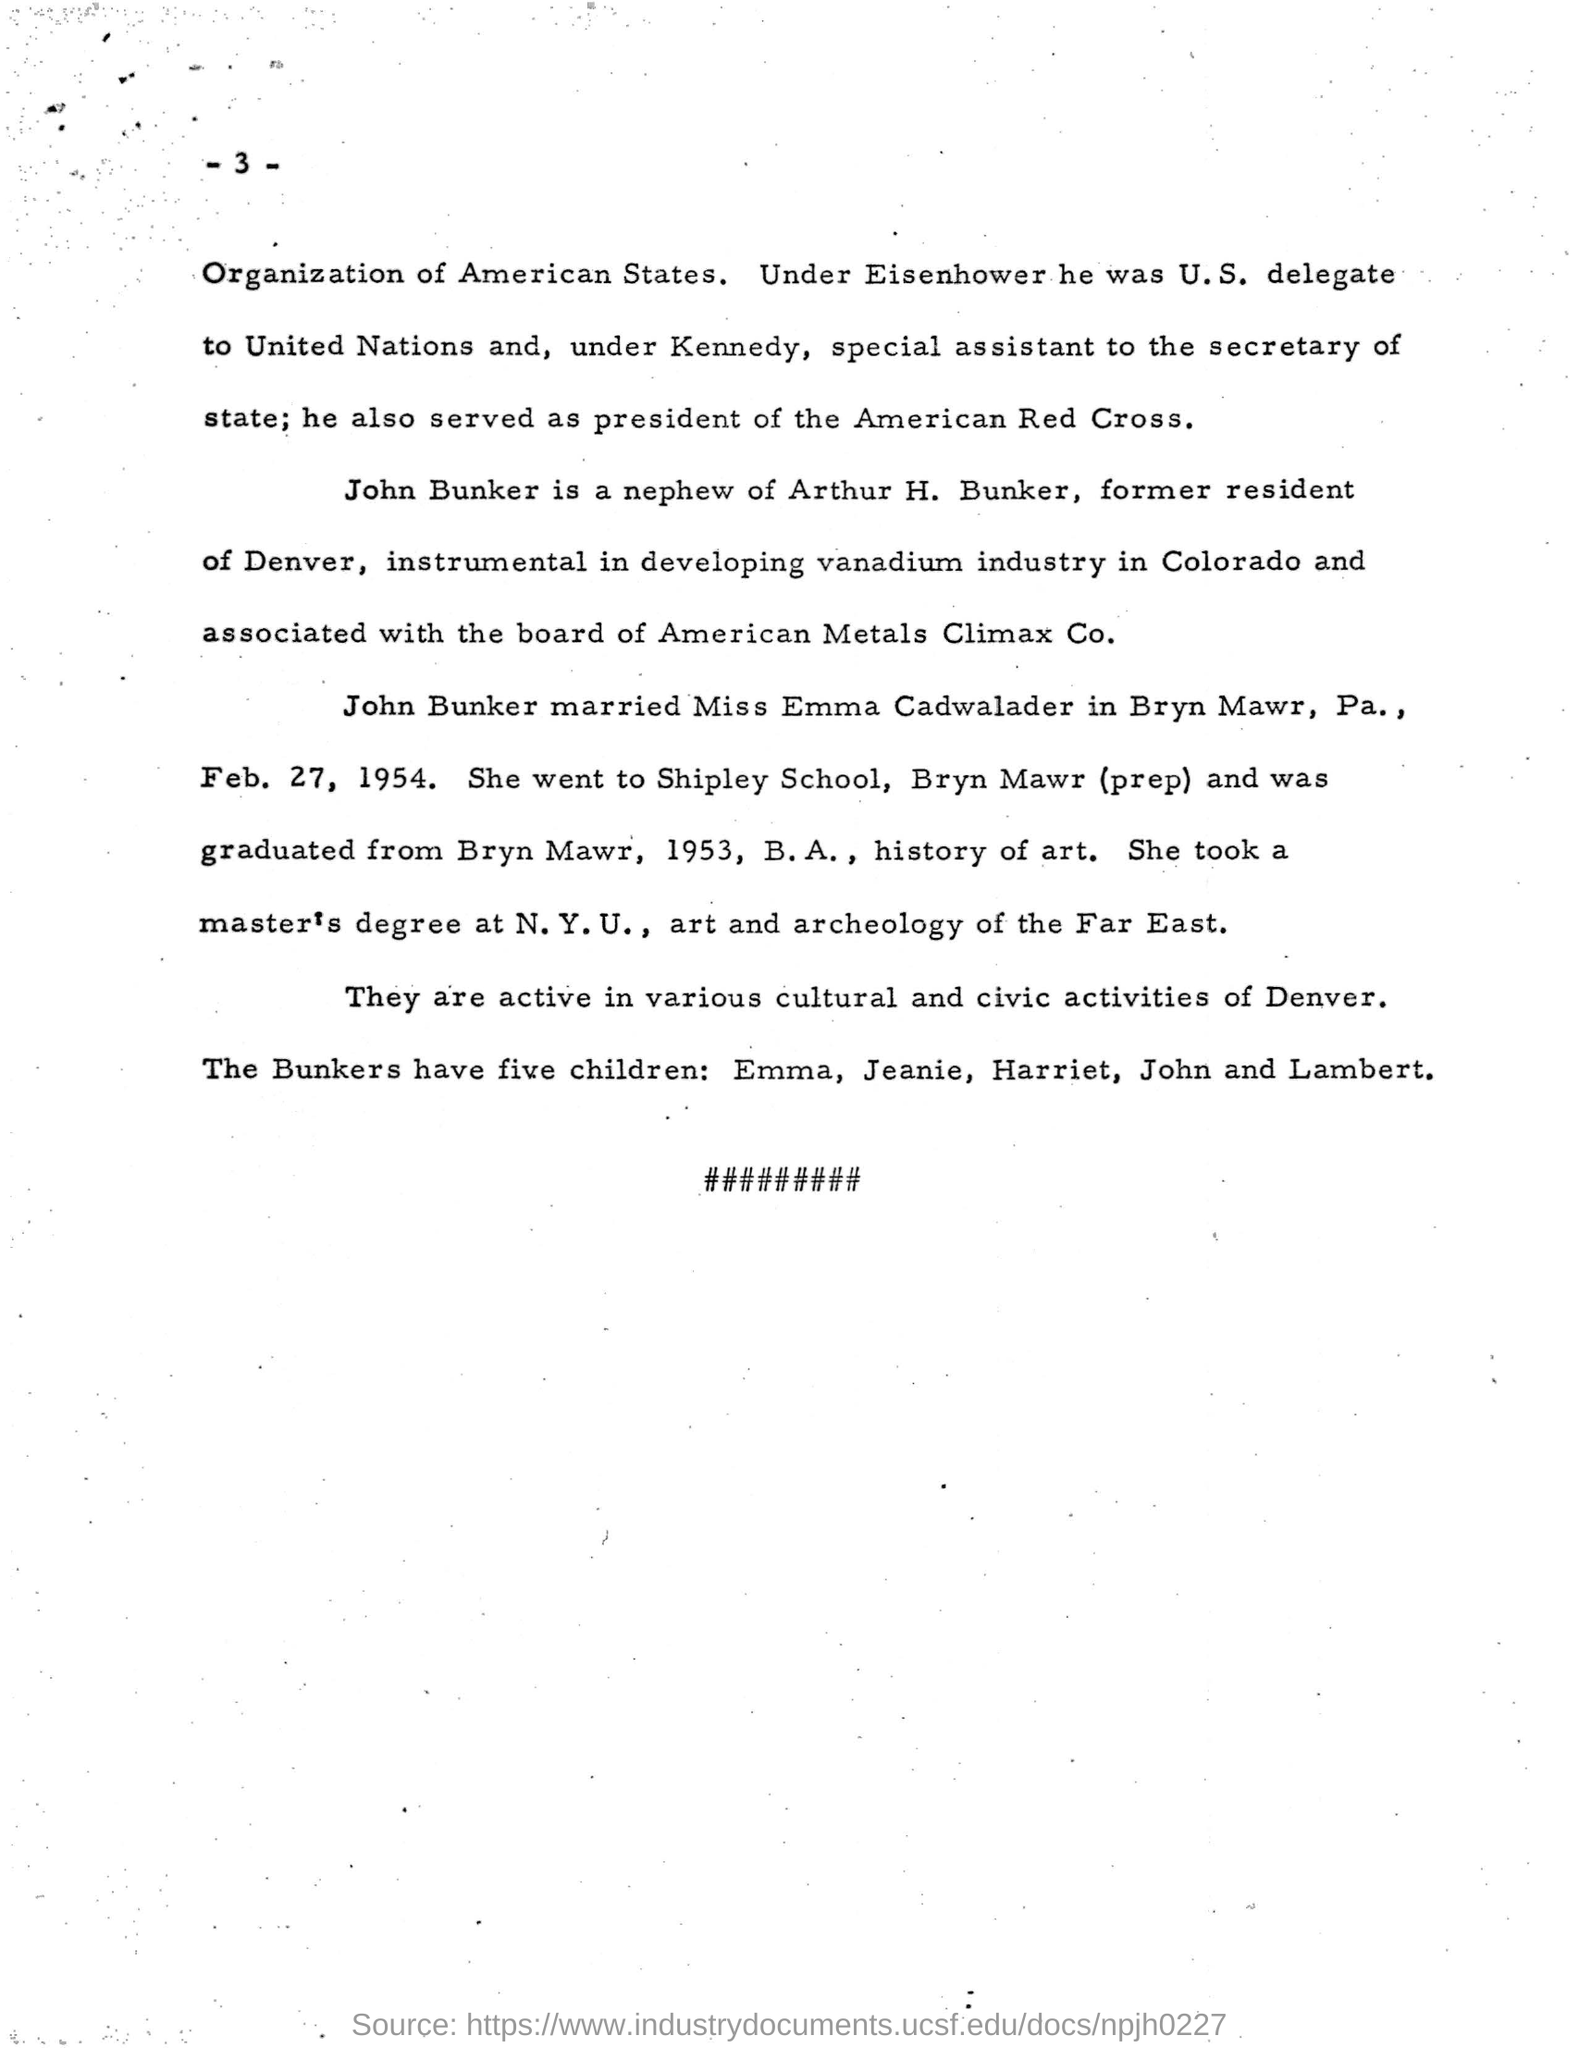Identify some key points in this picture. Miss Emma Cadwalader attended the Shipley School. John Bunker married Miss Emma Cadwalader. John Bunker is the nephew of Arthur H. Bunker. John Bunker is associated with the board of American Metals Climax Co. 